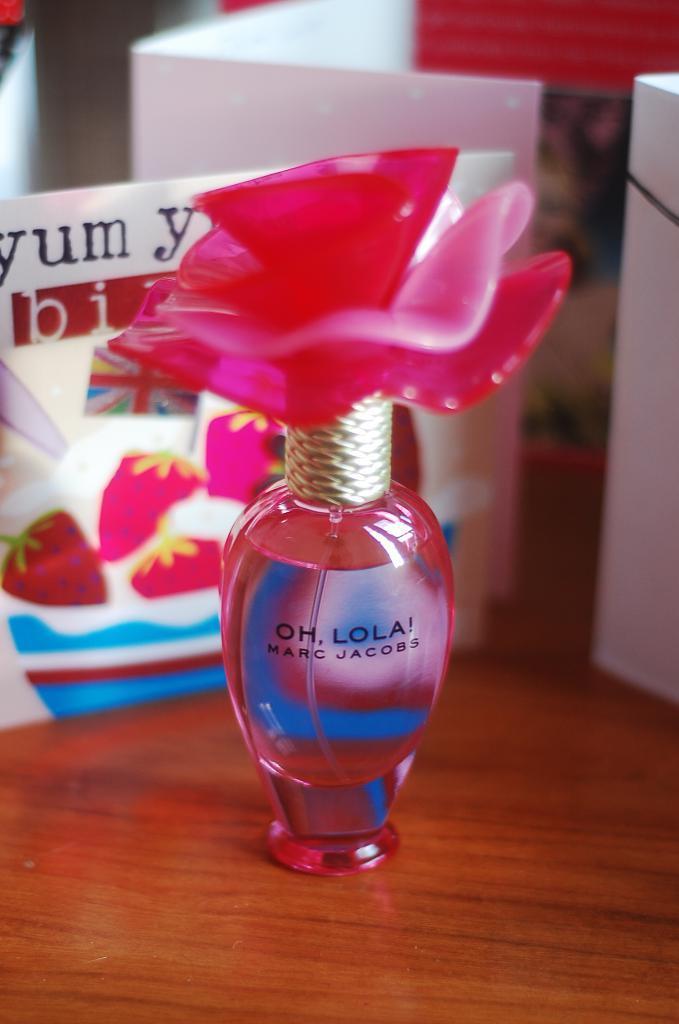<image>
Relay a brief, clear account of the picture shown. A small vial of Oh, Lola! is on a wooden table in front of cards. 